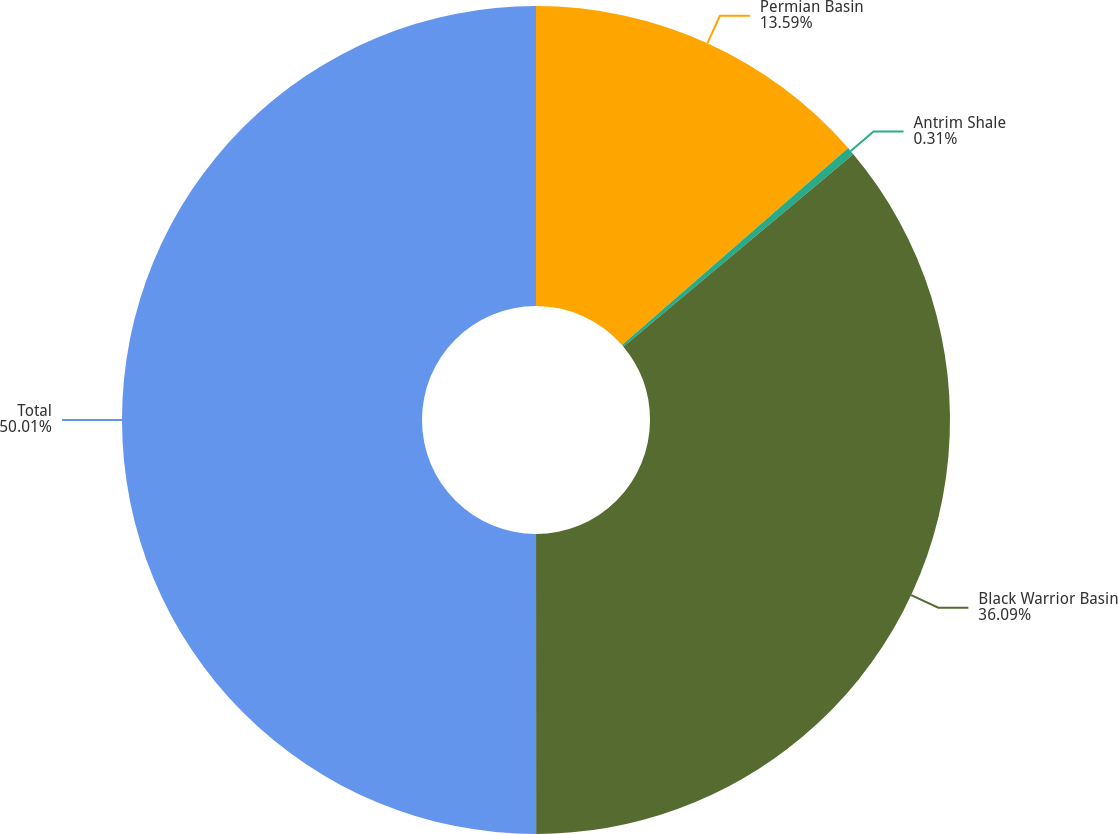<chart> <loc_0><loc_0><loc_500><loc_500><pie_chart><fcel>Permian Basin<fcel>Antrim Shale<fcel>Black Warrior Basin<fcel>Total<nl><fcel>13.59%<fcel>0.31%<fcel>36.09%<fcel>50.0%<nl></chart> 